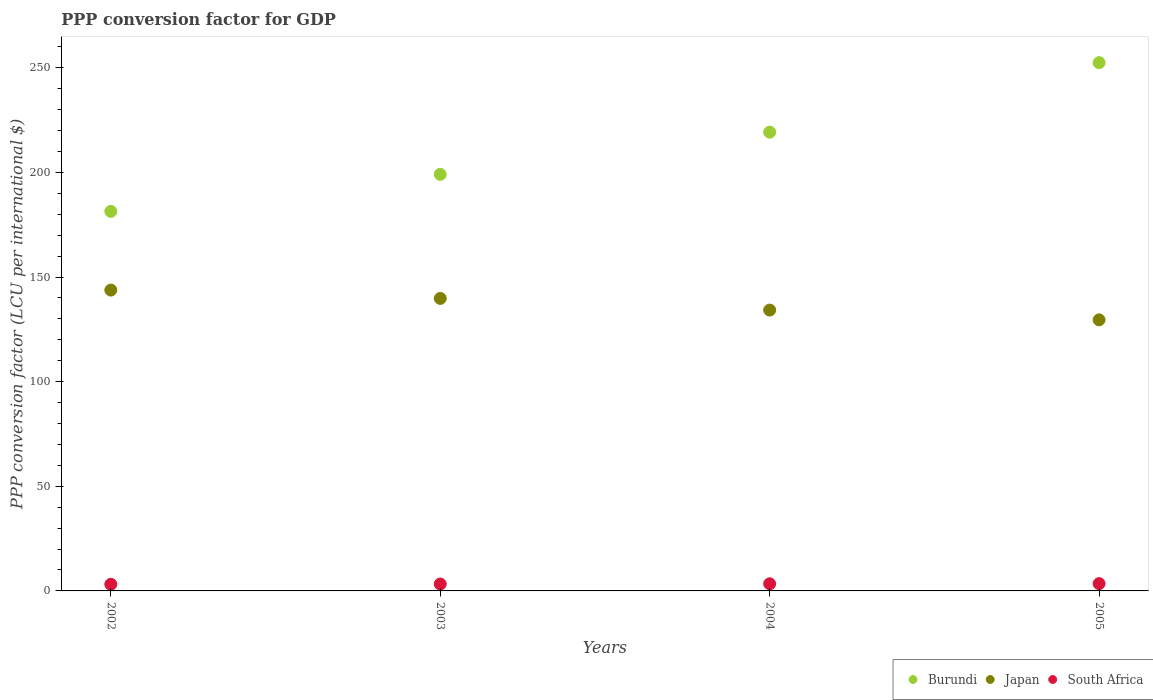Is the number of dotlines equal to the number of legend labels?
Provide a succinct answer. Yes. What is the PPP conversion factor for GDP in Burundi in 2005?
Ensure brevity in your answer.  252.46. Across all years, what is the maximum PPP conversion factor for GDP in Burundi?
Give a very brief answer. 252.46. Across all years, what is the minimum PPP conversion factor for GDP in South Africa?
Provide a succinct answer. 3.18. In which year was the PPP conversion factor for GDP in Burundi minimum?
Provide a short and direct response. 2002. What is the total PPP conversion factor for GDP in Burundi in the graph?
Provide a short and direct response. 852.21. What is the difference between the PPP conversion factor for GDP in Japan in 2003 and that in 2004?
Provide a succinct answer. 5.58. What is the difference between the PPP conversion factor for GDP in Japan in 2004 and the PPP conversion factor for GDP in Burundi in 2005?
Give a very brief answer. -118.25. What is the average PPP conversion factor for GDP in Japan per year?
Keep it short and to the point. 136.83. In the year 2003, what is the difference between the PPP conversion factor for GDP in Japan and PPP conversion factor for GDP in Burundi?
Provide a short and direct response. -59.31. In how many years, is the PPP conversion factor for GDP in Burundi greater than 220 LCU?
Make the answer very short. 1. What is the ratio of the PPP conversion factor for GDP in South Africa in 2002 to that in 2005?
Your answer should be compact. 0.91. What is the difference between the highest and the second highest PPP conversion factor for GDP in South Africa?
Offer a very short reply. 0.07. What is the difference between the highest and the lowest PPP conversion factor for GDP in Burundi?
Offer a very short reply. 71.06. In how many years, is the PPP conversion factor for GDP in South Africa greater than the average PPP conversion factor for GDP in South Africa taken over all years?
Offer a very short reply. 2. Is the sum of the PPP conversion factor for GDP in Burundi in 2002 and 2003 greater than the maximum PPP conversion factor for GDP in Japan across all years?
Your answer should be very brief. Yes. Is it the case that in every year, the sum of the PPP conversion factor for GDP in South Africa and PPP conversion factor for GDP in Japan  is greater than the PPP conversion factor for GDP in Burundi?
Offer a terse response. No. How many dotlines are there?
Give a very brief answer. 3. Are the values on the major ticks of Y-axis written in scientific E-notation?
Make the answer very short. No. How many legend labels are there?
Offer a very short reply. 3. What is the title of the graph?
Ensure brevity in your answer.  PPP conversion factor for GDP. Does "Afghanistan" appear as one of the legend labels in the graph?
Make the answer very short. No. What is the label or title of the Y-axis?
Offer a very short reply. PPP conversion factor (LCU per international $). What is the PPP conversion factor (LCU per international $) of Burundi in 2002?
Provide a succinct answer. 181.4. What is the PPP conversion factor (LCU per international $) of Japan in 2002?
Provide a short and direct response. 143.77. What is the PPP conversion factor (LCU per international $) in South Africa in 2002?
Keep it short and to the point. 3.18. What is the PPP conversion factor (LCU per international $) in Burundi in 2003?
Provide a succinct answer. 199.1. What is the PPP conversion factor (LCU per international $) of Japan in 2003?
Provide a succinct answer. 139.79. What is the PPP conversion factor (LCU per international $) of South Africa in 2003?
Your response must be concise. 3.3. What is the PPP conversion factor (LCU per international $) in Burundi in 2004?
Give a very brief answer. 219.24. What is the PPP conversion factor (LCU per international $) in Japan in 2004?
Offer a terse response. 134.21. What is the PPP conversion factor (LCU per international $) of South Africa in 2004?
Give a very brief answer. 3.42. What is the PPP conversion factor (LCU per international $) in Burundi in 2005?
Give a very brief answer. 252.46. What is the PPP conversion factor (LCU per international $) in Japan in 2005?
Offer a very short reply. 129.55. What is the PPP conversion factor (LCU per international $) of South Africa in 2005?
Your answer should be compact. 3.49. Across all years, what is the maximum PPP conversion factor (LCU per international $) of Burundi?
Give a very brief answer. 252.46. Across all years, what is the maximum PPP conversion factor (LCU per international $) of Japan?
Your response must be concise. 143.77. Across all years, what is the maximum PPP conversion factor (LCU per international $) in South Africa?
Offer a very short reply. 3.49. Across all years, what is the minimum PPP conversion factor (LCU per international $) in Burundi?
Make the answer very short. 181.4. Across all years, what is the minimum PPP conversion factor (LCU per international $) of Japan?
Your response must be concise. 129.55. Across all years, what is the minimum PPP conversion factor (LCU per international $) in South Africa?
Provide a succinct answer. 3.18. What is the total PPP conversion factor (LCU per international $) of Burundi in the graph?
Keep it short and to the point. 852.21. What is the total PPP conversion factor (LCU per international $) in Japan in the graph?
Keep it short and to the point. 547.33. What is the total PPP conversion factor (LCU per international $) in South Africa in the graph?
Give a very brief answer. 13.39. What is the difference between the PPP conversion factor (LCU per international $) of Burundi in 2002 and that in 2003?
Offer a terse response. -17.7. What is the difference between the PPP conversion factor (LCU per international $) in Japan in 2002 and that in 2003?
Offer a terse response. 3.98. What is the difference between the PPP conversion factor (LCU per international $) in South Africa in 2002 and that in 2003?
Give a very brief answer. -0.12. What is the difference between the PPP conversion factor (LCU per international $) in Burundi in 2002 and that in 2004?
Provide a succinct answer. -37.84. What is the difference between the PPP conversion factor (LCU per international $) of Japan in 2002 and that in 2004?
Your answer should be compact. 9.56. What is the difference between the PPP conversion factor (LCU per international $) in South Africa in 2002 and that in 2004?
Offer a terse response. -0.24. What is the difference between the PPP conversion factor (LCU per international $) of Burundi in 2002 and that in 2005?
Your response must be concise. -71.06. What is the difference between the PPP conversion factor (LCU per international $) of Japan in 2002 and that in 2005?
Ensure brevity in your answer.  14.22. What is the difference between the PPP conversion factor (LCU per international $) in South Africa in 2002 and that in 2005?
Offer a terse response. -0.31. What is the difference between the PPP conversion factor (LCU per international $) of Burundi in 2003 and that in 2004?
Offer a terse response. -20.15. What is the difference between the PPP conversion factor (LCU per international $) of Japan in 2003 and that in 2004?
Keep it short and to the point. 5.58. What is the difference between the PPP conversion factor (LCU per international $) of South Africa in 2003 and that in 2004?
Keep it short and to the point. -0.12. What is the difference between the PPP conversion factor (LCU per international $) of Burundi in 2003 and that in 2005?
Keep it short and to the point. -53.36. What is the difference between the PPP conversion factor (LCU per international $) of Japan in 2003 and that in 2005?
Keep it short and to the point. 10.24. What is the difference between the PPP conversion factor (LCU per international $) in South Africa in 2003 and that in 2005?
Provide a short and direct response. -0.2. What is the difference between the PPP conversion factor (LCU per international $) of Burundi in 2004 and that in 2005?
Provide a short and direct response. -33.22. What is the difference between the PPP conversion factor (LCU per international $) in Japan in 2004 and that in 2005?
Provide a short and direct response. 4.66. What is the difference between the PPP conversion factor (LCU per international $) in South Africa in 2004 and that in 2005?
Keep it short and to the point. -0.07. What is the difference between the PPP conversion factor (LCU per international $) of Burundi in 2002 and the PPP conversion factor (LCU per international $) of Japan in 2003?
Provide a short and direct response. 41.61. What is the difference between the PPP conversion factor (LCU per international $) of Burundi in 2002 and the PPP conversion factor (LCU per international $) of South Africa in 2003?
Ensure brevity in your answer.  178.1. What is the difference between the PPP conversion factor (LCU per international $) of Japan in 2002 and the PPP conversion factor (LCU per international $) of South Africa in 2003?
Provide a succinct answer. 140.48. What is the difference between the PPP conversion factor (LCU per international $) in Burundi in 2002 and the PPP conversion factor (LCU per international $) in Japan in 2004?
Give a very brief answer. 47.19. What is the difference between the PPP conversion factor (LCU per international $) of Burundi in 2002 and the PPP conversion factor (LCU per international $) of South Africa in 2004?
Give a very brief answer. 177.98. What is the difference between the PPP conversion factor (LCU per international $) in Japan in 2002 and the PPP conversion factor (LCU per international $) in South Africa in 2004?
Your answer should be compact. 140.36. What is the difference between the PPP conversion factor (LCU per international $) of Burundi in 2002 and the PPP conversion factor (LCU per international $) of Japan in 2005?
Give a very brief answer. 51.85. What is the difference between the PPP conversion factor (LCU per international $) of Burundi in 2002 and the PPP conversion factor (LCU per international $) of South Africa in 2005?
Provide a succinct answer. 177.91. What is the difference between the PPP conversion factor (LCU per international $) in Japan in 2002 and the PPP conversion factor (LCU per international $) in South Africa in 2005?
Offer a terse response. 140.28. What is the difference between the PPP conversion factor (LCU per international $) in Burundi in 2003 and the PPP conversion factor (LCU per international $) in Japan in 2004?
Your response must be concise. 64.89. What is the difference between the PPP conversion factor (LCU per international $) in Burundi in 2003 and the PPP conversion factor (LCU per international $) in South Africa in 2004?
Offer a very short reply. 195.68. What is the difference between the PPP conversion factor (LCU per international $) of Japan in 2003 and the PPP conversion factor (LCU per international $) of South Africa in 2004?
Make the answer very short. 136.37. What is the difference between the PPP conversion factor (LCU per international $) of Burundi in 2003 and the PPP conversion factor (LCU per international $) of Japan in 2005?
Give a very brief answer. 69.55. What is the difference between the PPP conversion factor (LCU per international $) in Burundi in 2003 and the PPP conversion factor (LCU per international $) in South Africa in 2005?
Ensure brevity in your answer.  195.61. What is the difference between the PPP conversion factor (LCU per international $) in Japan in 2003 and the PPP conversion factor (LCU per international $) in South Africa in 2005?
Offer a very short reply. 136.3. What is the difference between the PPP conversion factor (LCU per international $) in Burundi in 2004 and the PPP conversion factor (LCU per international $) in Japan in 2005?
Provide a short and direct response. 89.69. What is the difference between the PPP conversion factor (LCU per international $) of Burundi in 2004 and the PPP conversion factor (LCU per international $) of South Africa in 2005?
Your response must be concise. 215.75. What is the difference between the PPP conversion factor (LCU per international $) in Japan in 2004 and the PPP conversion factor (LCU per international $) in South Africa in 2005?
Offer a terse response. 130.72. What is the average PPP conversion factor (LCU per international $) of Burundi per year?
Your answer should be very brief. 213.05. What is the average PPP conversion factor (LCU per international $) of Japan per year?
Offer a terse response. 136.83. What is the average PPP conversion factor (LCU per international $) in South Africa per year?
Your response must be concise. 3.35. In the year 2002, what is the difference between the PPP conversion factor (LCU per international $) in Burundi and PPP conversion factor (LCU per international $) in Japan?
Your answer should be compact. 37.63. In the year 2002, what is the difference between the PPP conversion factor (LCU per international $) in Burundi and PPP conversion factor (LCU per international $) in South Africa?
Provide a succinct answer. 178.22. In the year 2002, what is the difference between the PPP conversion factor (LCU per international $) in Japan and PPP conversion factor (LCU per international $) in South Africa?
Give a very brief answer. 140.6. In the year 2003, what is the difference between the PPP conversion factor (LCU per international $) of Burundi and PPP conversion factor (LCU per international $) of Japan?
Provide a short and direct response. 59.31. In the year 2003, what is the difference between the PPP conversion factor (LCU per international $) in Burundi and PPP conversion factor (LCU per international $) in South Africa?
Keep it short and to the point. 195.8. In the year 2003, what is the difference between the PPP conversion factor (LCU per international $) in Japan and PPP conversion factor (LCU per international $) in South Africa?
Make the answer very short. 136.49. In the year 2004, what is the difference between the PPP conversion factor (LCU per international $) of Burundi and PPP conversion factor (LCU per international $) of Japan?
Ensure brevity in your answer.  85.03. In the year 2004, what is the difference between the PPP conversion factor (LCU per international $) in Burundi and PPP conversion factor (LCU per international $) in South Africa?
Make the answer very short. 215.83. In the year 2004, what is the difference between the PPP conversion factor (LCU per international $) in Japan and PPP conversion factor (LCU per international $) in South Africa?
Give a very brief answer. 130.79. In the year 2005, what is the difference between the PPP conversion factor (LCU per international $) in Burundi and PPP conversion factor (LCU per international $) in Japan?
Ensure brevity in your answer.  122.91. In the year 2005, what is the difference between the PPP conversion factor (LCU per international $) of Burundi and PPP conversion factor (LCU per international $) of South Africa?
Your answer should be very brief. 248.97. In the year 2005, what is the difference between the PPP conversion factor (LCU per international $) in Japan and PPP conversion factor (LCU per international $) in South Africa?
Keep it short and to the point. 126.06. What is the ratio of the PPP conversion factor (LCU per international $) in Burundi in 2002 to that in 2003?
Give a very brief answer. 0.91. What is the ratio of the PPP conversion factor (LCU per international $) of Japan in 2002 to that in 2003?
Provide a short and direct response. 1.03. What is the ratio of the PPP conversion factor (LCU per international $) in South Africa in 2002 to that in 2003?
Keep it short and to the point. 0.96. What is the ratio of the PPP conversion factor (LCU per international $) in Burundi in 2002 to that in 2004?
Make the answer very short. 0.83. What is the ratio of the PPP conversion factor (LCU per international $) of Japan in 2002 to that in 2004?
Offer a very short reply. 1.07. What is the ratio of the PPP conversion factor (LCU per international $) in South Africa in 2002 to that in 2004?
Your response must be concise. 0.93. What is the ratio of the PPP conversion factor (LCU per international $) of Burundi in 2002 to that in 2005?
Your response must be concise. 0.72. What is the ratio of the PPP conversion factor (LCU per international $) in Japan in 2002 to that in 2005?
Provide a succinct answer. 1.11. What is the ratio of the PPP conversion factor (LCU per international $) of South Africa in 2002 to that in 2005?
Give a very brief answer. 0.91. What is the ratio of the PPP conversion factor (LCU per international $) of Burundi in 2003 to that in 2004?
Your response must be concise. 0.91. What is the ratio of the PPP conversion factor (LCU per international $) of Japan in 2003 to that in 2004?
Your answer should be compact. 1.04. What is the ratio of the PPP conversion factor (LCU per international $) in South Africa in 2003 to that in 2004?
Ensure brevity in your answer.  0.96. What is the ratio of the PPP conversion factor (LCU per international $) of Burundi in 2003 to that in 2005?
Ensure brevity in your answer.  0.79. What is the ratio of the PPP conversion factor (LCU per international $) of Japan in 2003 to that in 2005?
Ensure brevity in your answer.  1.08. What is the ratio of the PPP conversion factor (LCU per international $) of South Africa in 2003 to that in 2005?
Make the answer very short. 0.94. What is the ratio of the PPP conversion factor (LCU per international $) of Burundi in 2004 to that in 2005?
Offer a very short reply. 0.87. What is the ratio of the PPP conversion factor (LCU per international $) of Japan in 2004 to that in 2005?
Give a very brief answer. 1.04. What is the ratio of the PPP conversion factor (LCU per international $) of South Africa in 2004 to that in 2005?
Ensure brevity in your answer.  0.98. What is the difference between the highest and the second highest PPP conversion factor (LCU per international $) in Burundi?
Your answer should be compact. 33.22. What is the difference between the highest and the second highest PPP conversion factor (LCU per international $) of Japan?
Your answer should be very brief. 3.98. What is the difference between the highest and the second highest PPP conversion factor (LCU per international $) in South Africa?
Your response must be concise. 0.07. What is the difference between the highest and the lowest PPP conversion factor (LCU per international $) in Burundi?
Make the answer very short. 71.06. What is the difference between the highest and the lowest PPP conversion factor (LCU per international $) of Japan?
Provide a succinct answer. 14.22. What is the difference between the highest and the lowest PPP conversion factor (LCU per international $) of South Africa?
Offer a terse response. 0.31. 